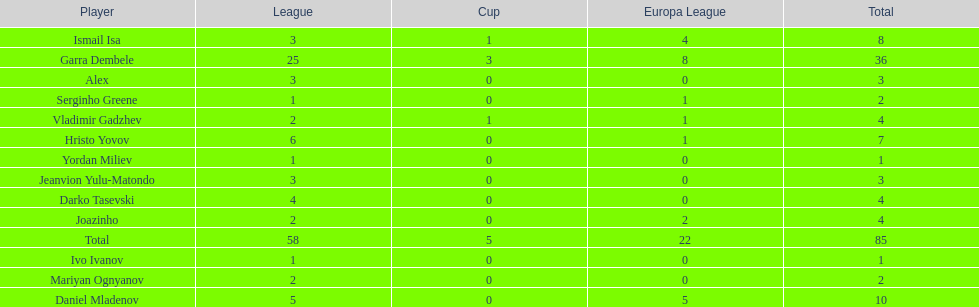Who was the top goalscorer on this team? Garra Dembele. 